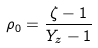<formula> <loc_0><loc_0><loc_500><loc_500>\rho _ { 0 } = \frac { \zeta - 1 } { Y _ { z } - 1 }</formula> 